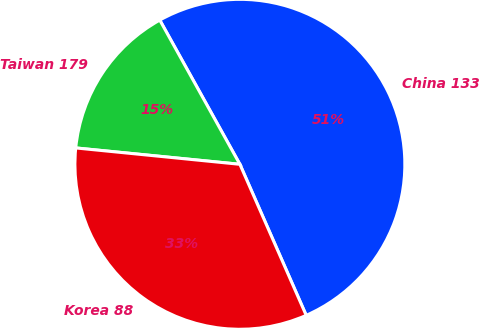Convert chart. <chart><loc_0><loc_0><loc_500><loc_500><pie_chart><fcel>China 133<fcel>Taiwan 179<fcel>Korea 88<nl><fcel>51.49%<fcel>15.35%<fcel>33.17%<nl></chart> 